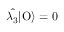<formula> <loc_0><loc_0><loc_500><loc_500>\hat { \lambda _ { 3 } } | O \rangle = 0</formula> 